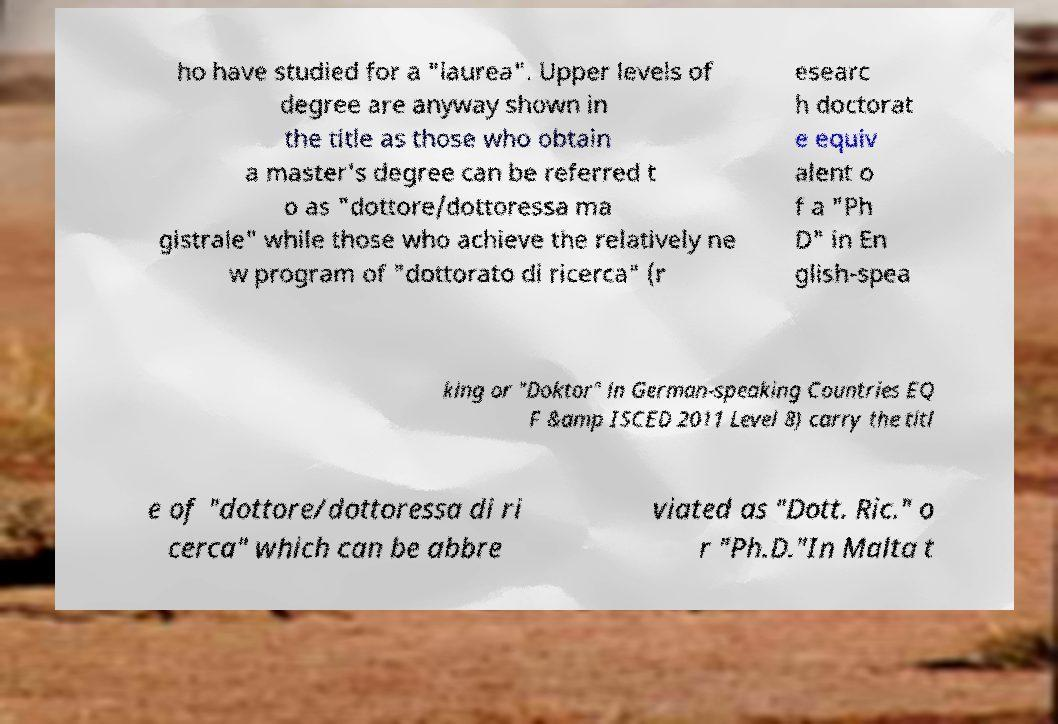Could you extract and type out the text from this image? ho have studied for a "laurea". Upper levels of degree are anyway shown in the title as those who obtain a master's degree can be referred t o as "dottore/dottoressa ma gistrale" while those who achieve the relatively ne w program of "dottorato di ricerca" (r esearc h doctorat e equiv alent o f a "Ph D" in En glish-spea king or "Doktor" in German-speaking Countries EQ F &amp ISCED 2011 Level 8) carry the titl e of "dottore/dottoressa di ri cerca" which can be abbre viated as "Dott. Ric." o r "Ph.D."In Malta t 